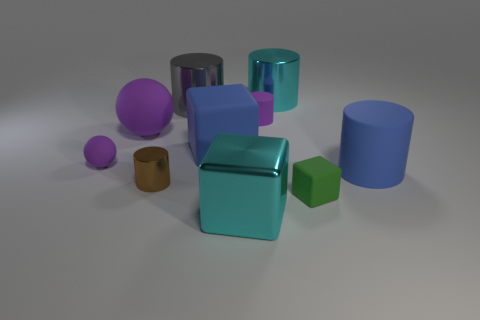There is another ball that is the same color as the big sphere; what size is it?
Your answer should be compact. Small. How many metal things are small blocks or large cyan cubes?
Your answer should be very brief. 1. Is there a big thing in front of the cube right of the object that is in front of the tiny green thing?
Give a very brief answer. Yes. What number of small rubber things are to the left of the green cube?
Offer a very short reply. 2. There is a small cylinder that is the same color as the big ball; what is its material?
Provide a succinct answer. Rubber. How many big objects are either matte spheres or cyan metallic cylinders?
Your answer should be compact. 2. There is a small purple object that is behind the large purple rubber ball; what shape is it?
Provide a succinct answer. Cylinder. Is there a big metal thing that has the same color as the small cube?
Give a very brief answer. No. There is a metal object in front of the small metallic thing; does it have the same size as the metal cylinder that is to the right of the gray object?
Offer a terse response. Yes. Are there more green things to the right of the big cyan shiny cylinder than objects right of the large sphere?
Ensure brevity in your answer.  No. 